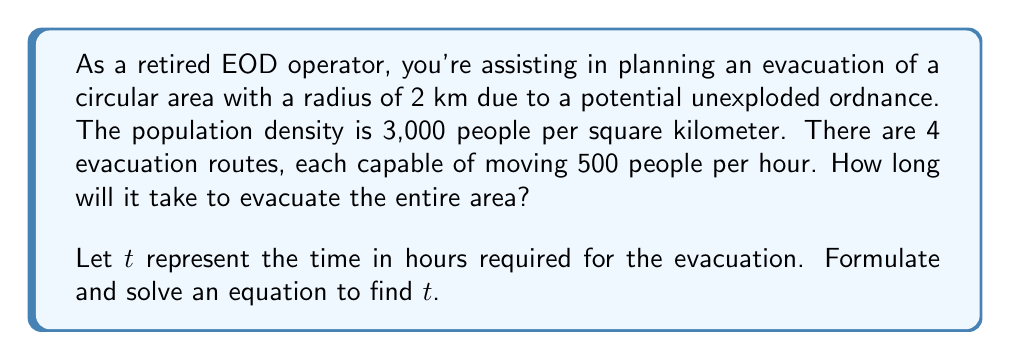Can you answer this question? To solve this problem, we'll follow these steps:

1) First, calculate the area of the circular region:
   $$A = \pi r^2 = \pi (2\text{ km})^2 = 4\pi \text{ km}^2$$

2) Next, determine the total population in this area:
   $$\text{Population} = \text{Area} \times \text{Density}$$
   $$\text{Population} = 4\pi \text{ km}^2 \times 3,000 \text{ people/km}^2 = 12,000\pi \text{ people}$$

3) Now, calculate the total evacuation rate:
   $$\text{Evacuation Rate} = 4 \text{ routes} \times 500 \text{ people/hour} = 2,000 \text{ people/hour}$$

4) Set up an equation where the number of people evacuated equals the total population:
   $$2,000t = 12,000\pi$$

5) Solve for $t$:
   $$t = \frac{12,000\pi}{2,000} = 6\pi \text{ hours}$$

6) Convert to hours and minutes:
   $$6\pi \text{ hours} = 18.85 \text{ hours} \approx 18 \text{ hours and } 51 \text{ minutes}$$
Answer: The evacuation will take approximately 18 hours and 51 minutes. 